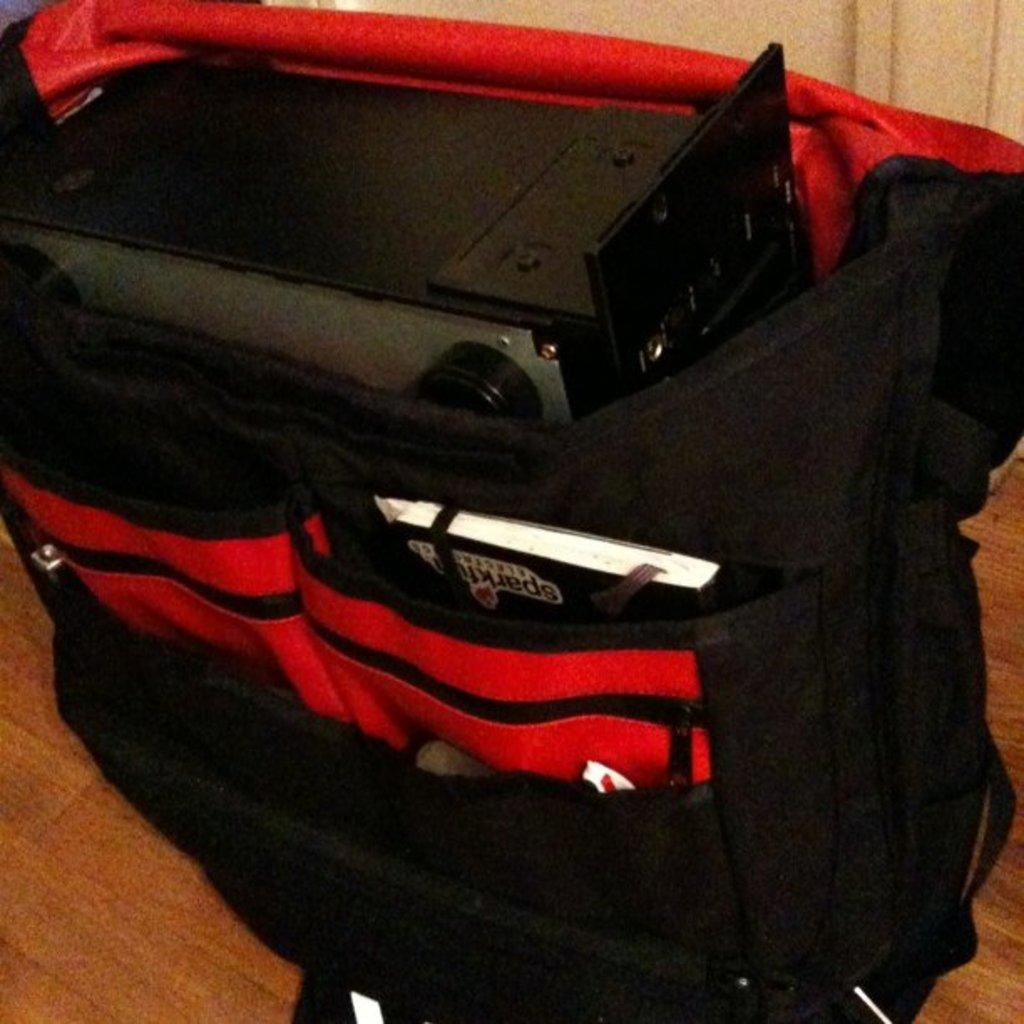What is inside the bag that is visible in the image? There is an object in a bag in the image. What type of teeth can be seen in the image? There are no teeth visible in the image. What type of destruction is occurring in the image? There is no destruction present in the image. What type of train can be seen in the image? There is no train present in the image. 